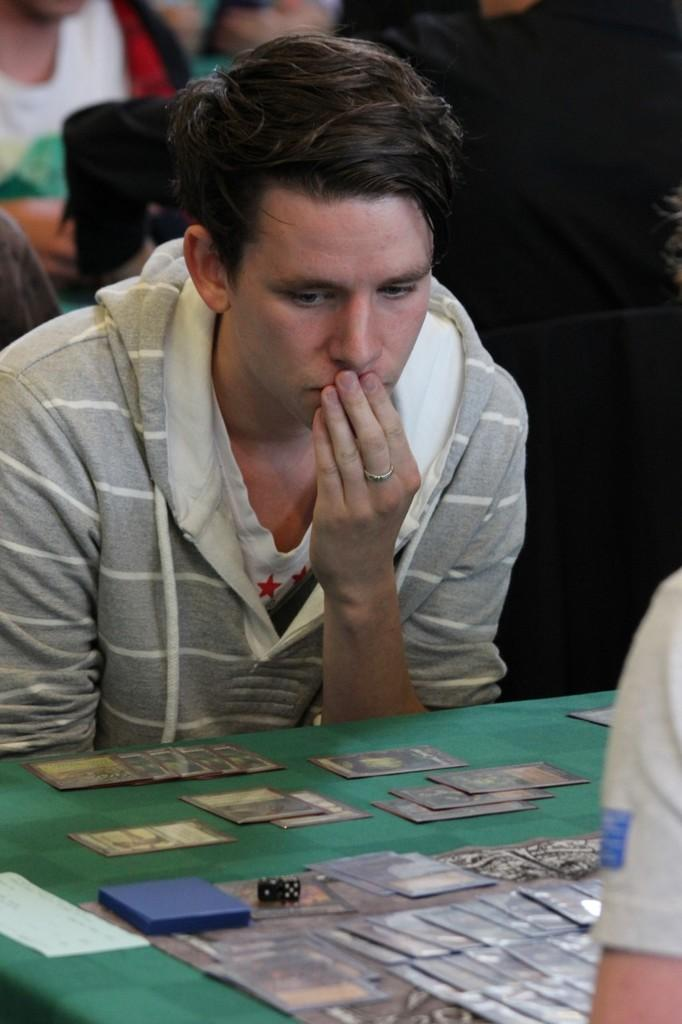Who is present in the image? There is a man in the image. What object can be seen in the image besides the man? There is a table in the image. What is on the table? There are cards on the table. Can you describe the setting in the background of the image? There are people visible in the background of the image. What type of bread is being served on the table in the image? There is no bread present in the image; it features a man, a table, cards, and people in the background. 